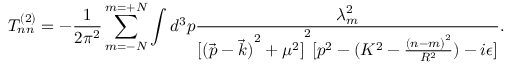<formula> <loc_0><loc_0><loc_500><loc_500>T _ { n n } ^ { ( 2 ) } = - \frac { 1 } { 2 \pi ^ { 2 } } \sum _ { m = - N } ^ { m = + N } \int d ^ { 3 } p \frac { \lambda _ { m } ^ { 2 } } { { [ { ( \vec { p } - \vec { k } ) } ^ { 2 } + \mu ^ { 2 } ] } ^ { 2 } [ p ^ { 2 } - ( K ^ { 2 } - \frac { { ( n - m ) } ^ { 2 } } { R ^ { 2 } } ) - i \epsilon ] } .</formula> 